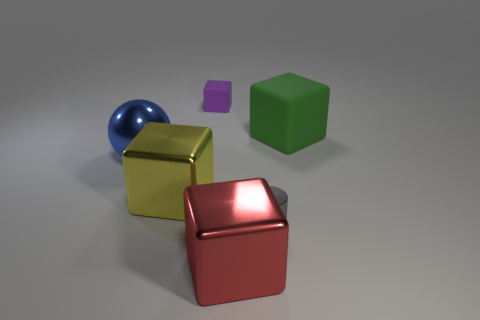There is a rubber thing that is to the right of the small gray shiny cylinder; are there any gray cylinders that are right of it? no 